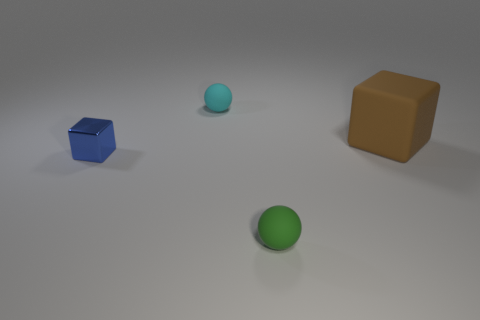Add 2 tiny matte balls. How many objects exist? 6 Subtract all brown blocks. How many blocks are left? 1 Subtract all green matte cylinders. Subtract all balls. How many objects are left? 2 Add 2 green objects. How many green objects are left? 3 Add 2 cyan things. How many cyan things exist? 3 Subtract 0 green cylinders. How many objects are left? 4 Subtract 1 cubes. How many cubes are left? 1 Subtract all green balls. Subtract all purple cubes. How many balls are left? 1 Subtract all purple spheres. How many gray cubes are left? 0 